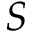<formula> <loc_0><loc_0><loc_500><loc_500>S</formula> 